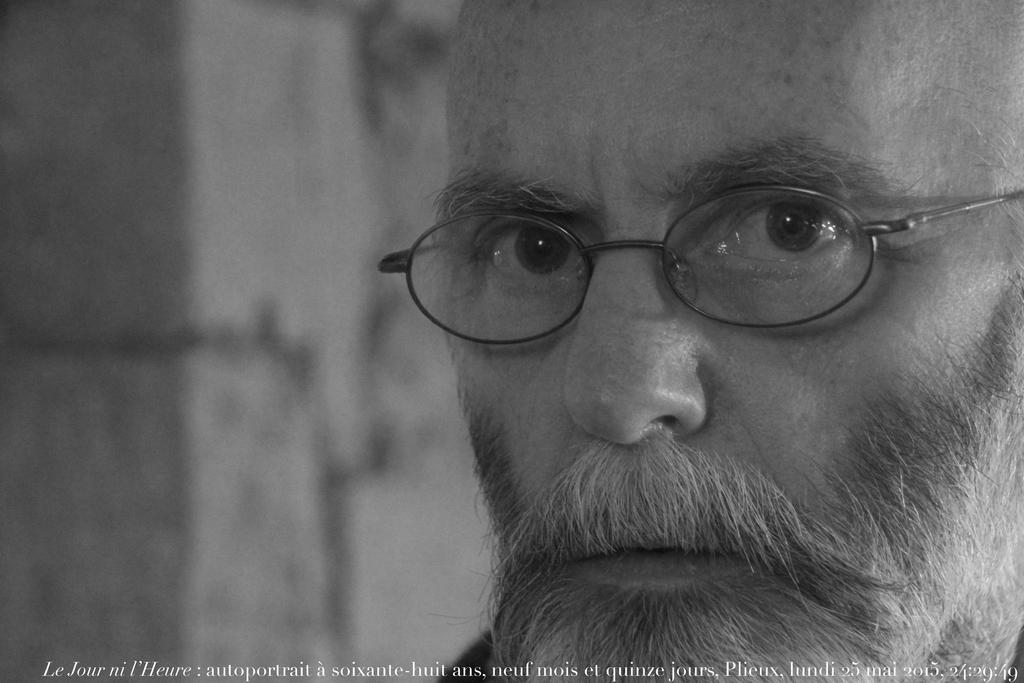What can be seen in the image? There is a person in the image. Can you describe the person's appearance? The person is wearing spectacles. What is present at the bottom of the image? There is text and numbers at the bottom of the image. How would you describe the background of the image? The background of the image is blurry. What time is displayed on the clock in the image? There is no clock present in the image. What type of drug is the person taking in the image? There is no drug present in the image, and the person's actions are not depicted. 